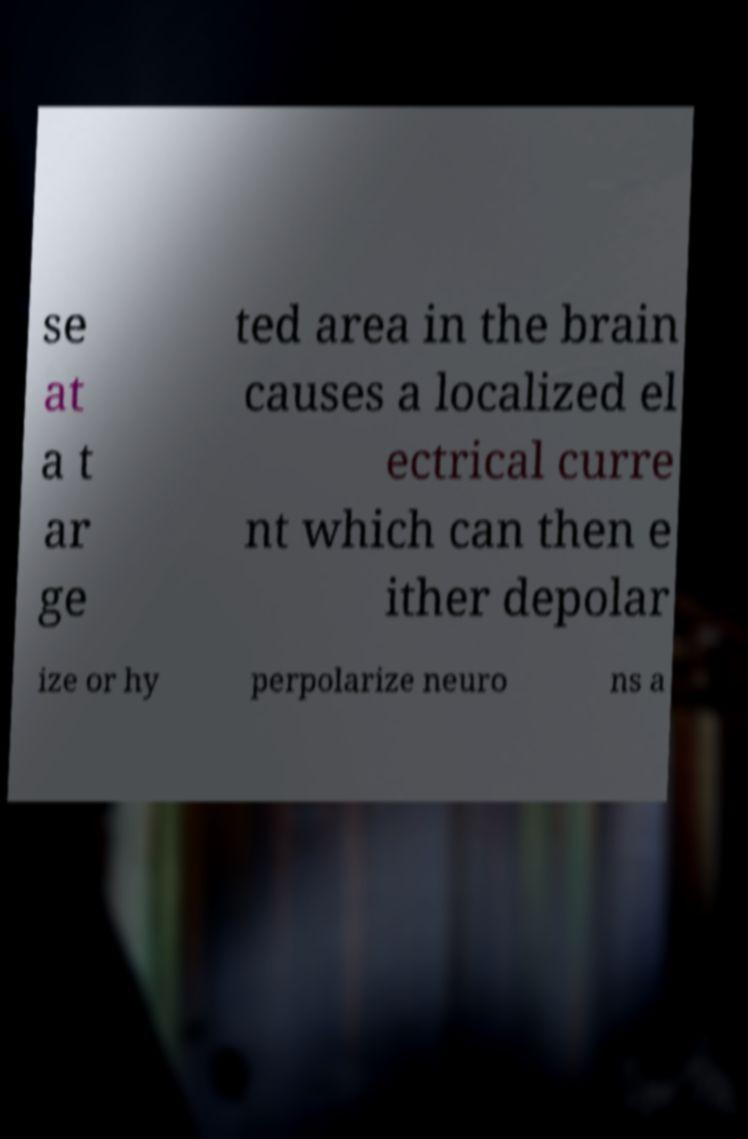There's text embedded in this image that I need extracted. Can you transcribe it verbatim? se at a t ar ge ted area in the brain causes a localized el ectrical curre nt which can then e ither depolar ize or hy perpolarize neuro ns a 